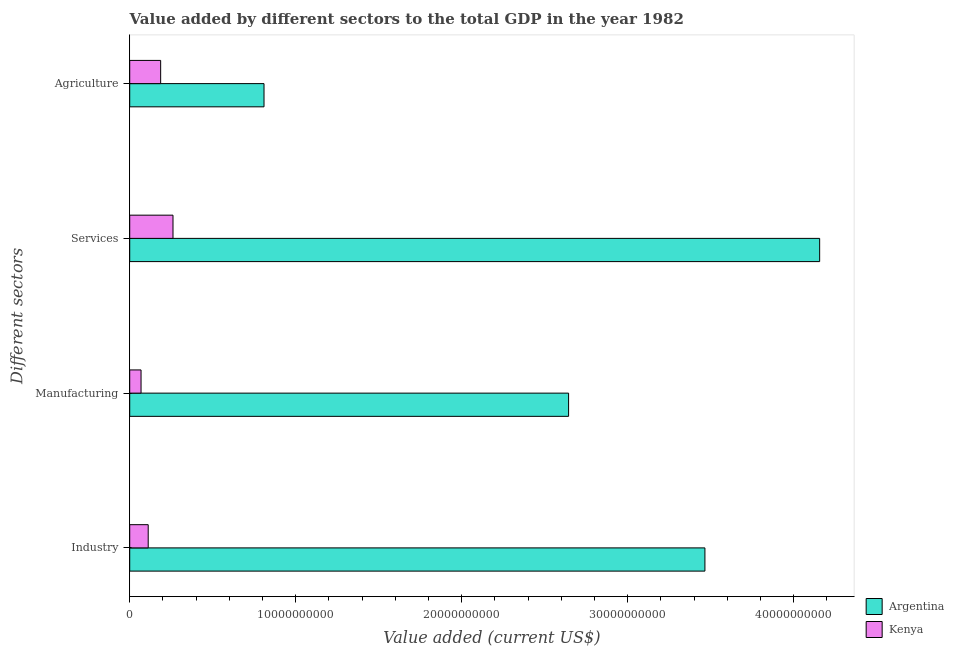How many groups of bars are there?
Your response must be concise. 4. How many bars are there on the 3rd tick from the top?
Make the answer very short. 2. How many bars are there on the 3rd tick from the bottom?
Give a very brief answer. 2. What is the label of the 4th group of bars from the top?
Your response must be concise. Industry. What is the value added by services sector in Argentina?
Offer a very short reply. 4.16e+1. Across all countries, what is the maximum value added by manufacturing sector?
Ensure brevity in your answer.  2.64e+1. Across all countries, what is the minimum value added by services sector?
Make the answer very short. 2.61e+09. In which country was the value added by services sector maximum?
Make the answer very short. Argentina. In which country was the value added by agricultural sector minimum?
Your response must be concise. Kenya. What is the total value added by services sector in the graph?
Your answer should be compact. 4.42e+1. What is the difference between the value added by agricultural sector in Kenya and that in Argentina?
Make the answer very short. -6.23e+09. What is the difference between the value added by manufacturing sector in Kenya and the value added by agricultural sector in Argentina?
Your answer should be compact. -7.41e+09. What is the average value added by services sector per country?
Provide a short and direct response. 2.21e+1. What is the difference between the value added by industrial sector and value added by agricultural sector in Kenya?
Your answer should be very brief. -7.50e+08. In how many countries, is the value added by agricultural sector greater than 8000000000 US$?
Your answer should be compact. 1. What is the ratio of the value added by manufacturing sector in Argentina to that in Kenya?
Your answer should be very brief. 38.78. Is the difference between the value added by manufacturing sector in Kenya and Argentina greater than the difference between the value added by services sector in Kenya and Argentina?
Give a very brief answer. Yes. What is the difference between the highest and the second highest value added by services sector?
Provide a short and direct response. 3.90e+1. What is the difference between the highest and the lowest value added by services sector?
Your response must be concise. 3.90e+1. Is it the case that in every country, the sum of the value added by industrial sector and value added by agricultural sector is greater than the sum of value added by services sector and value added by manufacturing sector?
Your answer should be compact. No. What does the 1st bar from the top in Services represents?
Your answer should be compact. Kenya. What does the 2nd bar from the bottom in Agriculture represents?
Provide a short and direct response. Kenya. Is it the case that in every country, the sum of the value added by industrial sector and value added by manufacturing sector is greater than the value added by services sector?
Your response must be concise. No. How many bars are there?
Provide a succinct answer. 8. Are all the bars in the graph horizontal?
Give a very brief answer. Yes. How many countries are there in the graph?
Provide a short and direct response. 2. What is the difference between two consecutive major ticks on the X-axis?
Offer a terse response. 1.00e+1. Does the graph contain any zero values?
Offer a terse response. No. How many legend labels are there?
Keep it short and to the point. 2. What is the title of the graph?
Your response must be concise. Value added by different sectors to the total GDP in the year 1982. What is the label or title of the X-axis?
Offer a very short reply. Value added (current US$). What is the label or title of the Y-axis?
Keep it short and to the point. Different sectors. What is the Value added (current US$) in Argentina in Industry?
Give a very brief answer. 3.47e+1. What is the Value added (current US$) in Kenya in Industry?
Offer a terse response. 1.11e+09. What is the Value added (current US$) in Argentina in Manufacturing?
Your response must be concise. 2.64e+1. What is the Value added (current US$) of Kenya in Manufacturing?
Provide a succinct answer. 6.82e+08. What is the Value added (current US$) in Argentina in Services?
Make the answer very short. 4.16e+1. What is the Value added (current US$) in Kenya in Services?
Your answer should be compact. 2.61e+09. What is the Value added (current US$) in Argentina in Agriculture?
Your answer should be compact. 8.09e+09. What is the Value added (current US$) in Kenya in Agriculture?
Make the answer very short. 1.86e+09. Across all Different sectors, what is the maximum Value added (current US$) in Argentina?
Give a very brief answer. 4.16e+1. Across all Different sectors, what is the maximum Value added (current US$) of Kenya?
Keep it short and to the point. 2.61e+09. Across all Different sectors, what is the minimum Value added (current US$) in Argentina?
Provide a succinct answer. 8.09e+09. Across all Different sectors, what is the minimum Value added (current US$) in Kenya?
Offer a terse response. 6.82e+08. What is the total Value added (current US$) in Argentina in the graph?
Your response must be concise. 1.11e+11. What is the total Value added (current US$) of Kenya in the graph?
Your answer should be very brief. 6.27e+09. What is the difference between the Value added (current US$) in Argentina in Industry and that in Manufacturing?
Provide a short and direct response. 8.21e+09. What is the difference between the Value added (current US$) in Kenya in Industry and that in Manufacturing?
Offer a terse response. 4.32e+08. What is the difference between the Value added (current US$) of Argentina in Industry and that in Services?
Make the answer very short. -6.91e+09. What is the difference between the Value added (current US$) of Kenya in Industry and that in Services?
Provide a succinct answer. -1.49e+09. What is the difference between the Value added (current US$) in Argentina in Industry and that in Agriculture?
Keep it short and to the point. 2.66e+1. What is the difference between the Value added (current US$) in Kenya in Industry and that in Agriculture?
Your answer should be compact. -7.50e+08. What is the difference between the Value added (current US$) in Argentina in Manufacturing and that in Services?
Your answer should be very brief. -1.51e+1. What is the difference between the Value added (current US$) of Kenya in Manufacturing and that in Services?
Provide a short and direct response. -1.93e+09. What is the difference between the Value added (current US$) in Argentina in Manufacturing and that in Agriculture?
Your answer should be compact. 1.83e+1. What is the difference between the Value added (current US$) of Kenya in Manufacturing and that in Agriculture?
Keep it short and to the point. -1.18e+09. What is the difference between the Value added (current US$) of Argentina in Services and that in Agriculture?
Offer a very short reply. 3.35e+1. What is the difference between the Value added (current US$) of Kenya in Services and that in Agriculture?
Offer a very short reply. 7.44e+08. What is the difference between the Value added (current US$) of Argentina in Industry and the Value added (current US$) of Kenya in Manufacturing?
Make the answer very short. 3.40e+1. What is the difference between the Value added (current US$) of Argentina in Industry and the Value added (current US$) of Kenya in Services?
Keep it short and to the point. 3.20e+1. What is the difference between the Value added (current US$) of Argentina in Industry and the Value added (current US$) of Kenya in Agriculture?
Ensure brevity in your answer.  3.28e+1. What is the difference between the Value added (current US$) in Argentina in Manufacturing and the Value added (current US$) in Kenya in Services?
Ensure brevity in your answer.  2.38e+1. What is the difference between the Value added (current US$) of Argentina in Manufacturing and the Value added (current US$) of Kenya in Agriculture?
Make the answer very short. 2.46e+1. What is the difference between the Value added (current US$) of Argentina in Services and the Value added (current US$) of Kenya in Agriculture?
Keep it short and to the point. 3.97e+1. What is the average Value added (current US$) of Argentina per Different sectors?
Ensure brevity in your answer.  2.77e+1. What is the average Value added (current US$) in Kenya per Different sectors?
Make the answer very short. 1.57e+09. What is the difference between the Value added (current US$) of Argentina and Value added (current US$) of Kenya in Industry?
Give a very brief answer. 3.35e+1. What is the difference between the Value added (current US$) of Argentina and Value added (current US$) of Kenya in Manufacturing?
Make the answer very short. 2.58e+1. What is the difference between the Value added (current US$) of Argentina and Value added (current US$) of Kenya in Services?
Your response must be concise. 3.90e+1. What is the difference between the Value added (current US$) in Argentina and Value added (current US$) in Kenya in Agriculture?
Provide a succinct answer. 6.23e+09. What is the ratio of the Value added (current US$) in Argentina in Industry to that in Manufacturing?
Your answer should be compact. 1.31. What is the ratio of the Value added (current US$) of Kenya in Industry to that in Manufacturing?
Your answer should be compact. 1.63. What is the ratio of the Value added (current US$) in Argentina in Industry to that in Services?
Your response must be concise. 0.83. What is the ratio of the Value added (current US$) of Kenya in Industry to that in Services?
Provide a short and direct response. 0.43. What is the ratio of the Value added (current US$) of Argentina in Industry to that in Agriculture?
Ensure brevity in your answer.  4.28. What is the ratio of the Value added (current US$) in Kenya in Industry to that in Agriculture?
Your answer should be compact. 0.6. What is the ratio of the Value added (current US$) in Argentina in Manufacturing to that in Services?
Your response must be concise. 0.64. What is the ratio of the Value added (current US$) in Kenya in Manufacturing to that in Services?
Provide a short and direct response. 0.26. What is the ratio of the Value added (current US$) in Argentina in Manufacturing to that in Agriculture?
Make the answer very short. 3.27. What is the ratio of the Value added (current US$) of Kenya in Manufacturing to that in Agriculture?
Give a very brief answer. 0.37. What is the ratio of the Value added (current US$) of Argentina in Services to that in Agriculture?
Offer a terse response. 5.14. What is the ratio of the Value added (current US$) of Kenya in Services to that in Agriculture?
Provide a short and direct response. 1.4. What is the difference between the highest and the second highest Value added (current US$) of Argentina?
Offer a very short reply. 6.91e+09. What is the difference between the highest and the second highest Value added (current US$) of Kenya?
Provide a succinct answer. 7.44e+08. What is the difference between the highest and the lowest Value added (current US$) in Argentina?
Offer a very short reply. 3.35e+1. What is the difference between the highest and the lowest Value added (current US$) of Kenya?
Your answer should be compact. 1.93e+09. 